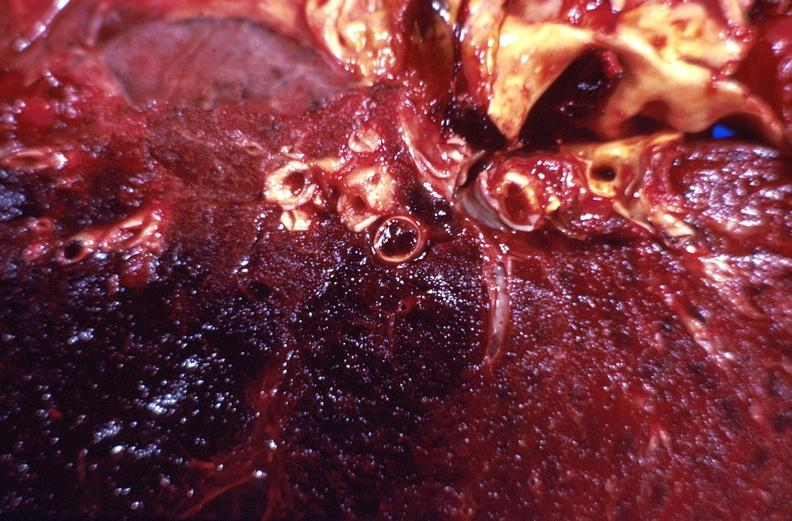how does this image show subacute pulmonary thromboembolus?
Answer the question using a single word or phrase. With acute infarct 